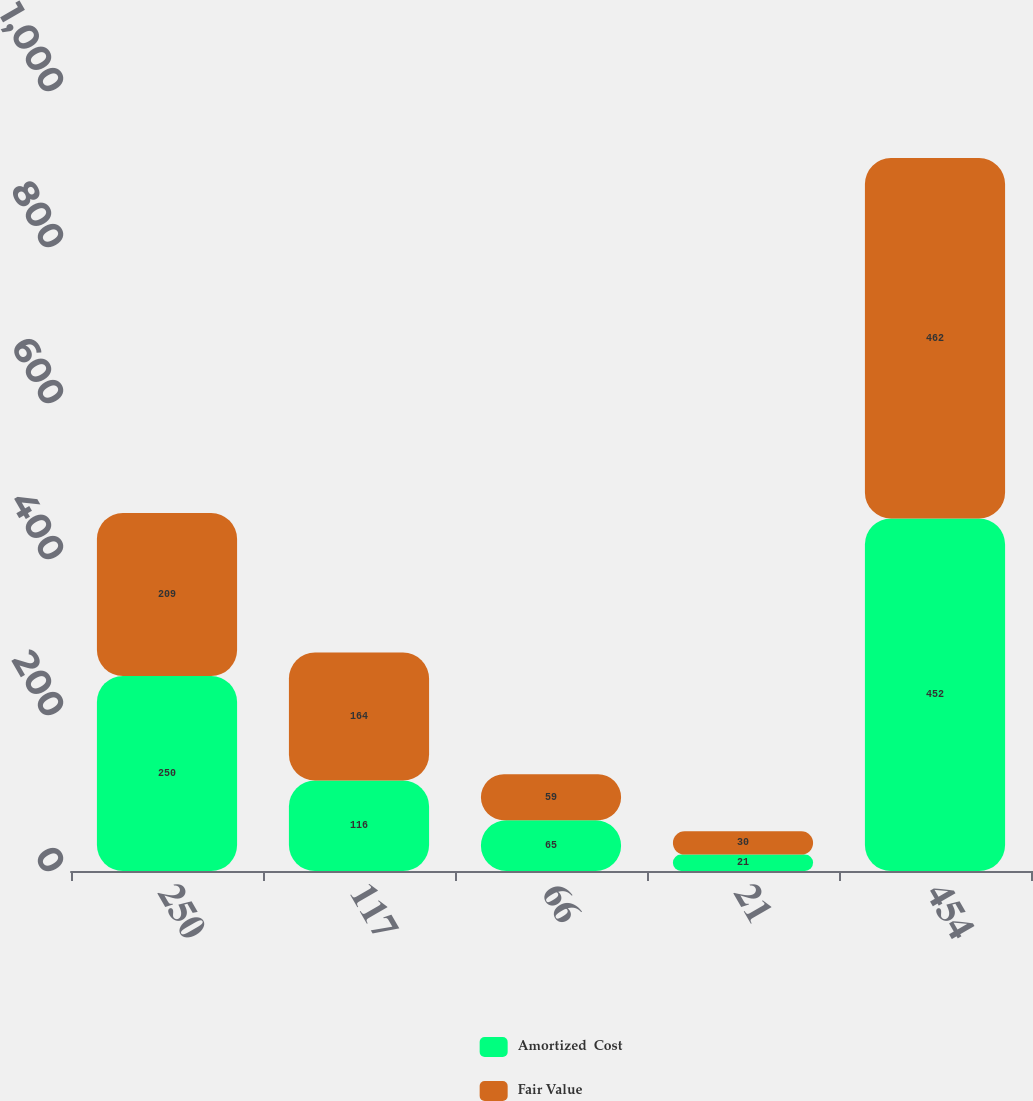<chart> <loc_0><loc_0><loc_500><loc_500><stacked_bar_chart><ecel><fcel>250<fcel>117<fcel>66<fcel>21<fcel>454<nl><fcel>Amortized  Cost<fcel>250<fcel>116<fcel>65<fcel>21<fcel>452<nl><fcel>Fair Value<fcel>209<fcel>164<fcel>59<fcel>30<fcel>462<nl></chart> 